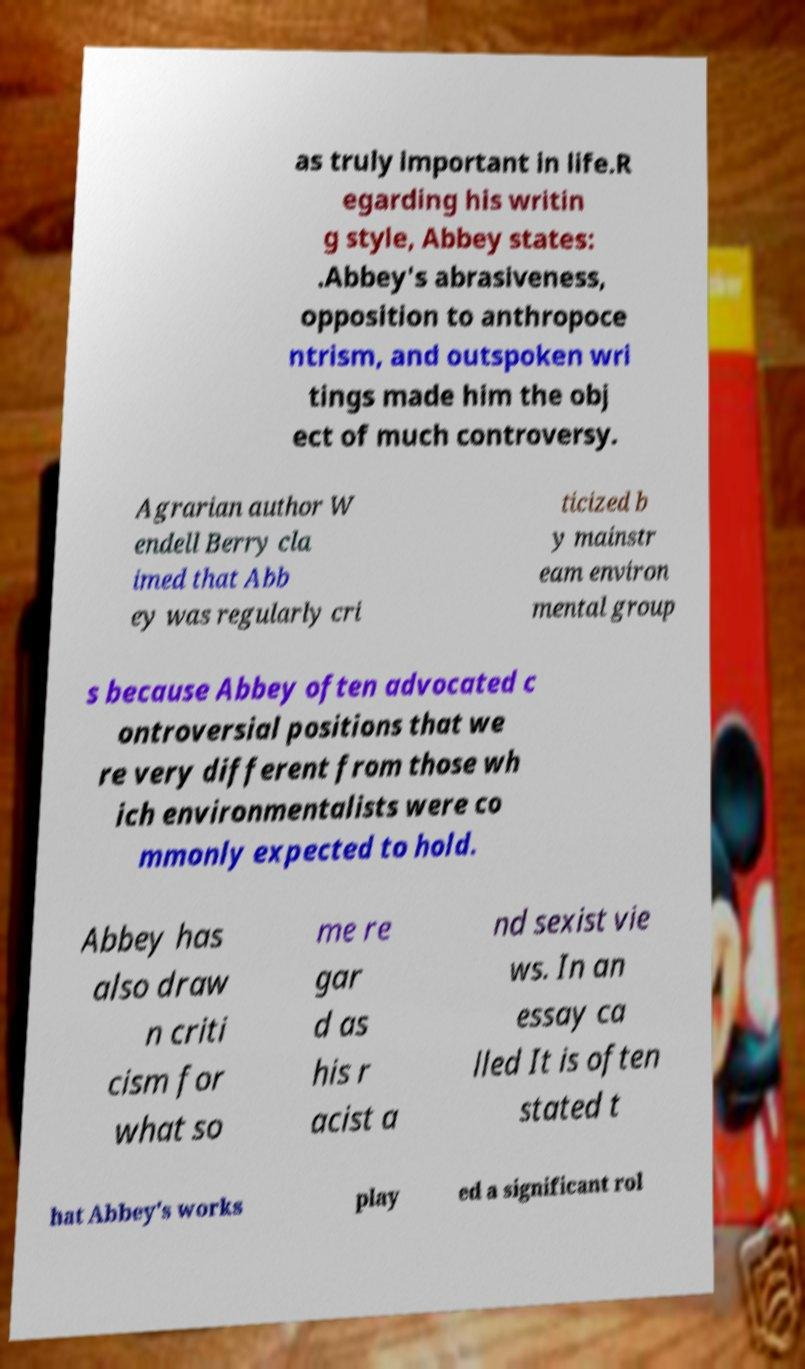For documentation purposes, I need the text within this image transcribed. Could you provide that? as truly important in life.R egarding his writin g style, Abbey states: .Abbey's abrasiveness, opposition to anthropoce ntrism, and outspoken wri tings made him the obj ect of much controversy. Agrarian author W endell Berry cla imed that Abb ey was regularly cri ticized b y mainstr eam environ mental group s because Abbey often advocated c ontroversial positions that we re very different from those wh ich environmentalists were co mmonly expected to hold. Abbey has also draw n criti cism for what so me re gar d as his r acist a nd sexist vie ws. In an essay ca lled It is often stated t hat Abbey's works play ed a significant rol 